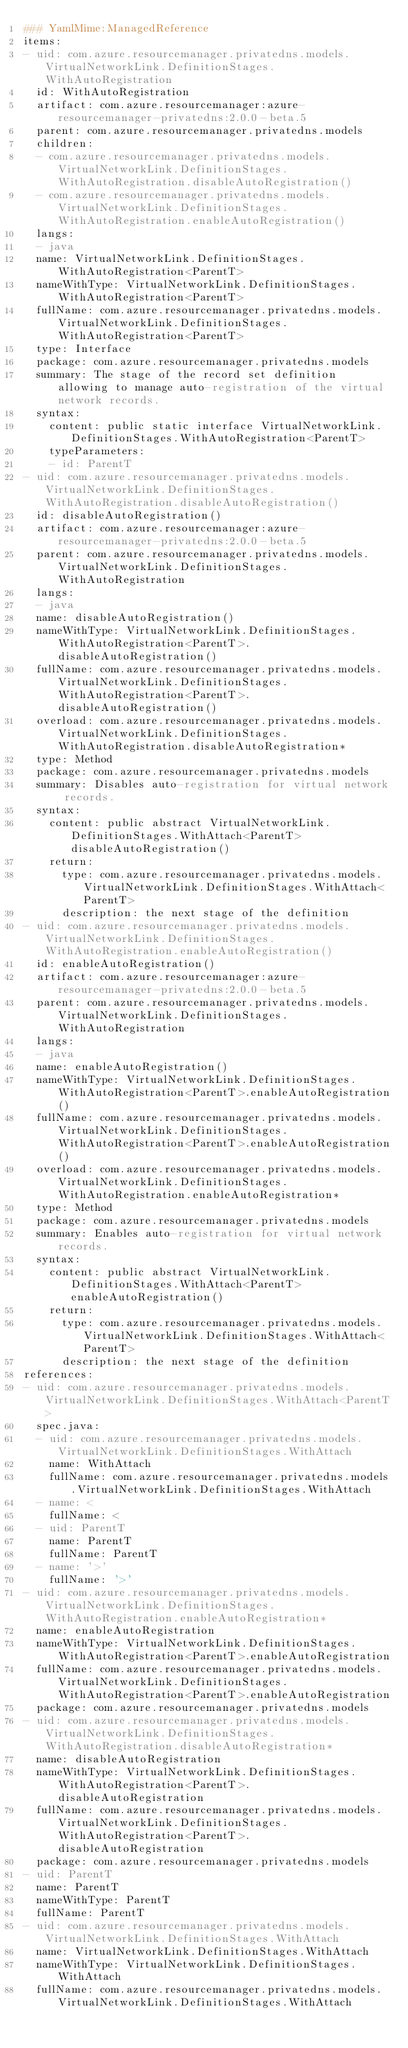Convert code to text. <code><loc_0><loc_0><loc_500><loc_500><_YAML_>### YamlMime:ManagedReference
items:
- uid: com.azure.resourcemanager.privatedns.models.VirtualNetworkLink.DefinitionStages.WithAutoRegistration
  id: WithAutoRegistration
  artifact: com.azure.resourcemanager:azure-resourcemanager-privatedns:2.0.0-beta.5
  parent: com.azure.resourcemanager.privatedns.models
  children:
  - com.azure.resourcemanager.privatedns.models.VirtualNetworkLink.DefinitionStages.WithAutoRegistration.disableAutoRegistration()
  - com.azure.resourcemanager.privatedns.models.VirtualNetworkLink.DefinitionStages.WithAutoRegistration.enableAutoRegistration()
  langs:
  - java
  name: VirtualNetworkLink.DefinitionStages.WithAutoRegistration<ParentT>
  nameWithType: VirtualNetworkLink.DefinitionStages.WithAutoRegistration<ParentT>
  fullName: com.azure.resourcemanager.privatedns.models.VirtualNetworkLink.DefinitionStages.WithAutoRegistration<ParentT>
  type: Interface
  package: com.azure.resourcemanager.privatedns.models
  summary: The stage of the record set definition allowing to manage auto-registration of the virtual network records.
  syntax:
    content: public static interface VirtualNetworkLink.DefinitionStages.WithAutoRegistration<ParentT>
    typeParameters:
    - id: ParentT
- uid: com.azure.resourcemanager.privatedns.models.VirtualNetworkLink.DefinitionStages.WithAutoRegistration.disableAutoRegistration()
  id: disableAutoRegistration()
  artifact: com.azure.resourcemanager:azure-resourcemanager-privatedns:2.0.0-beta.5
  parent: com.azure.resourcemanager.privatedns.models.VirtualNetworkLink.DefinitionStages.WithAutoRegistration
  langs:
  - java
  name: disableAutoRegistration()
  nameWithType: VirtualNetworkLink.DefinitionStages.WithAutoRegistration<ParentT>.disableAutoRegistration()
  fullName: com.azure.resourcemanager.privatedns.models.VirtualNetworkLink.DefinitionStages.WithAutoRegistration<ParentT>.disableAutoRegistration()
  overload: com.azure.resourcemanager.privatedns.models.VirtualNetworkLink.DefinitionStages.WithAutoRegistration.disableAutoRegistration*
  type: Method
  package: com.azure.resourcemanager.privatedns.models
  summary: Disables auto-registration for virtual network records.
  syntax:
    content: public abstract VirtualNetworkLink.DefinitionStages.WithAttach<ParentT> disableAutoRegistration()
    return:
      type: com.azure.resourcemanager.privatedns.models.VirtualNetworkLink.DefinitionStages.WithAttach<ParentT>
      description: the next stage of the definition
- uid: com.azure.resourcemanager.privatedns.models.VirtualNetworkLink.DefinitionStages.WithAutoRegistration.enableAutoRegistration()
  id: enableAutoRegistration()
  artifact: com.azure.resourcemanager:azure-resourcemanager-privatedns:2.0.0-beta.5
  parent: com.azure.resourcemanager.privatedns.models.VirtualNetworkLink.DefinitionStages.WithAutoRegistration
  langs:
  - java
  name: enableAutoRegistration()
  nameWithType: VirtualNetworkLink.DefinitionStages.WithAutoRegistration<ParentT>.enableAutoRegistration()
  fullName: com.azure.resourcemanager.privatedns.models.VirtualNetworkLink.DefinitionStages.WithAutoRegistration<ParentT>.enableAutoRegistration()
  overload: com.azure.resourcemanager.privatedns.models.VirtualNetworkLink.DefinitionStages.WithAutoRegistration.enableAutoRegistration*
  type: Method
  package: com.azure.resourcemanager.privatedns.models
  summary: Enables auto-registration for virtual network records.
  syntax:
    content: public abstract VirtualNetworkLink.DefinitionStages.WithAttach<ParentT> enableAutoRegistration()
    return:
      type: com.azure.resourcemanager.privatedns.models.VirtualNetworkLink.DefinitionStages.WithAttach<ParentT>
      description: the next stage of the definition
references:
- uid: com.azure.resourcemanager.privatedns.models.VirtualNetworkLink.DefinitionStages.WithAttach<ParentT>
  spec.java:
  - uid: com.azure.resourcemanager.privatedns.models.VirtualNetworkLink.DefinitionStages.WithAttach
    name: WithAttach
    fullName: com.azure.resourcemanager.privatedns.models.VirtualNetworkLink.DefinitionStages.WithAttach
  - name: <
    fullName: <
  - uid: ParentT
    name: ParentT
    fullName: ParentT
  - name: '>'
    fullName: '>'
- uid: com.azure.resourcemanager.privatedns.models.VirtualNetworkLink.DefinitionStages.WithAutoRegistration.enableAutoRegistration*
  name: enableAutoRegistration
  nameWithType: VirtualNetworkLink.DefinitionStages.WithAutoRegistration<ParentT>.enableAutoRegistration
  fullName: com.azure.resourcemanager.privatedns.models.VirtualNetworkLink.DefinitionStages.WithAutoRegistration<ParentT>.enableAutoRegistration
  package: com.azure.resourcemanager.privatedns.models
- uid: com.azure.resourcemanager.privatedns.models.VirtualNetworkLink.DefinitionStages.WithAutoRegistration.disableAutoRegistration*
  name: disableAutoRegistration
  nameWithType: VirtualNetworkLink.DefinitionStages.WithAutoRegistration<ParentT>.disableAutoRegistration
  fullName: com.azure.resourcemanager.privatedns.models.VirtualNetworkLink.DefinitionStages.WithAutoRegistration<ParentT>.disableAutoRegistration
  package: com.azure.resourcemanager.privatedns.models
- uid: ParentT
  name: ParentT
  nameWithType: ParentT
  fullName: ParentT
- uid: com.azure.resourcemanager.privatedns.models.VirtualNetworkLink.DefinitionStages.WithAttach
  name: VirtualNetworkLink.DefinitionStages.WithAttach
  nameWithType: VirtualNetworkLink.DefinitionStages.WithAttach
  fullName: com.azure.resourcemanager.privatedns.models.VirtualNetworkLink.DefinitionStages.WithAttach
</code> 